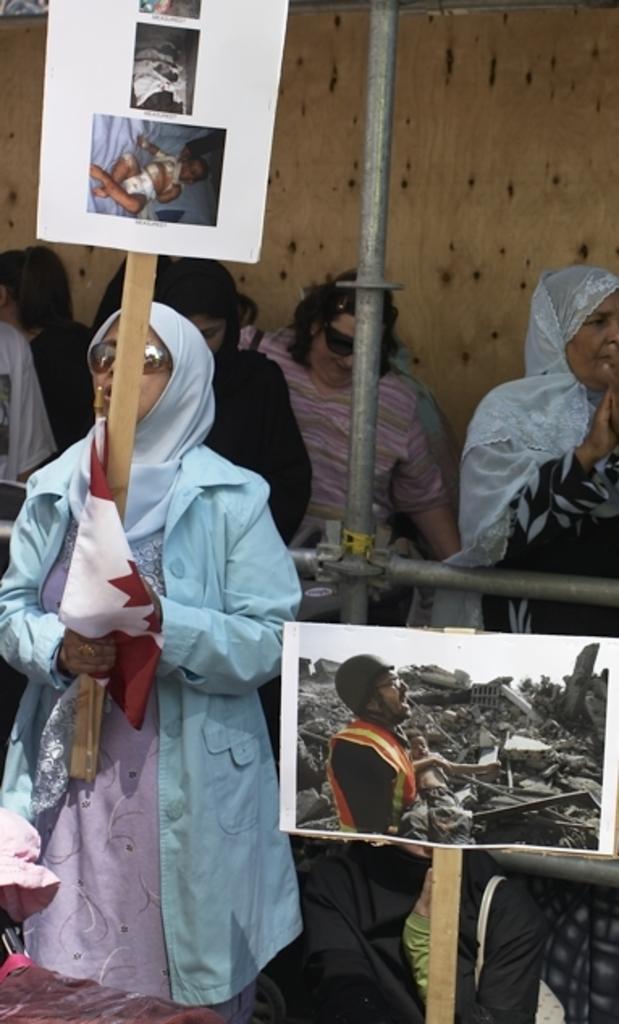Can you describe this image briefly? At the bottom left side of the image, we can see a hat and a cloth on some object. In the center of the image we can see rods, one person is sitting and a few people are standing and they are in different costumes. Among them, we can see two persons are holding placards and one person is holding a flag. On the placards, we can see a few people and a few other objects. In the background there is a wooden wall. 